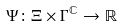Convert formula to latex. <formula><loc_0><loc_0><loc_500><loc_500>\Psi \colon \Xi \times \Gamma ^ { \mathbb { C } } \rightarrow \mathbb { R }</formula> 